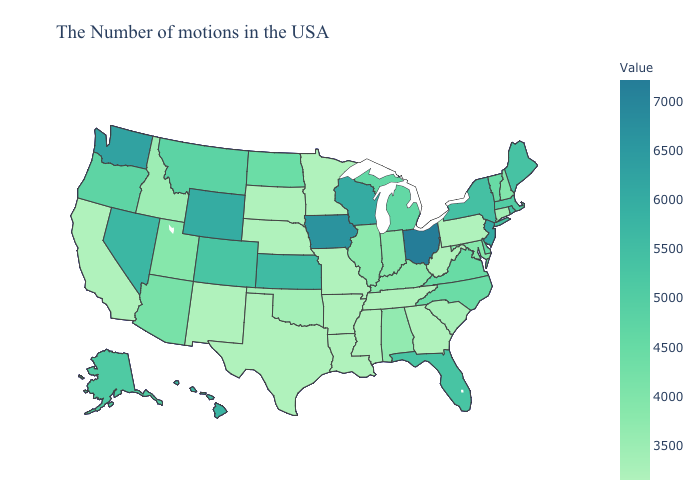Does Nebraska have the lowest value in the USA?
Quick response, please. Yes. Among the states that border Vermont , which have the highest value?
Quick response, please. New York. Among the states that border Minnesota , which have the lowest value?
Be succinct. South Dakota. Does California have the lowest value in the USA?
Short answer required. Yes. Does Pennsylvania have the highest value in the USA?
Give a very brief answer. No. Which states hav the highest value in the South?
Write a very short answer. Florida. Does Montana have a lower value than Oklahoma?
Write a very short answer. No. 